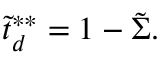Convert formula to latex. <formula><loc_0><loc_0><loc_500><loc_500>\tilde { t } _ { d } ^ { * * } = 1 - \tilde { \Sigma } .</formula> 